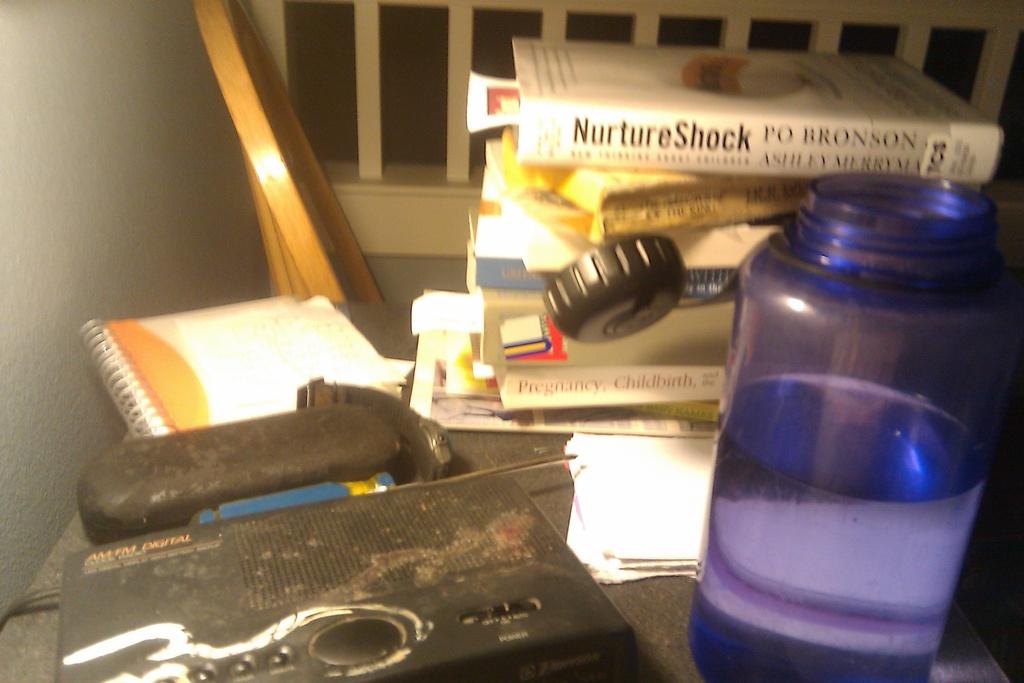What are the first names of the authors of nurture shock?
Offer a terse response. Po and ashley. What is the title of the top book?
Ensure brevity in your answer.  Nurture shock. 